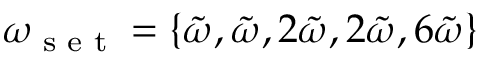Convert formula to latex. <formula><loc_0><loc_0><loc_500><loc_500>\omega _ { s e t } = \{ \tilde { \omega } , \tilde { \omega } , 2 \tilde { \omega } , 2 \tilde { \omega } , 6 \tilde { \omega } \}</formula> 